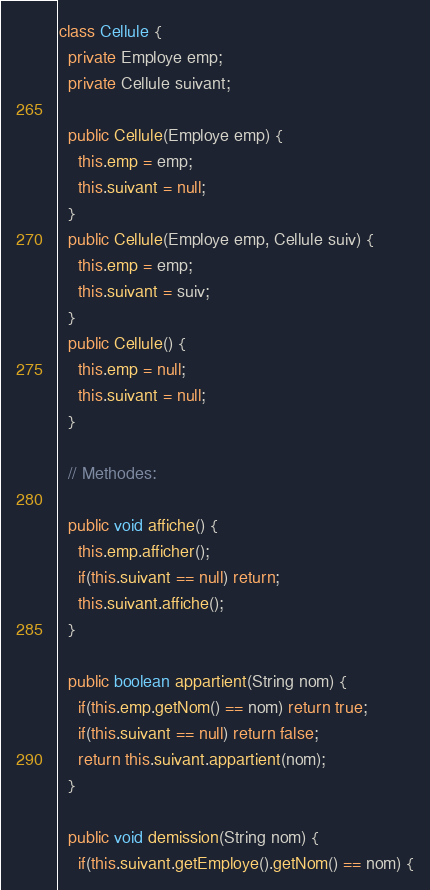Convert code to text. <code><loc_0><loc_0><loc_500><loc_500><_Java_>class Cellule {
  private Employe emp;
  private Cellule suivant;

  public Cellule(Employe emp) {
    this.emp = emp;
    this.suivant = null;
  }
  public Cellule(Employe emp, Cellule suiv) {
    this.emp = emp;
    this.suivant = suiv;
  }
  public Cellule() {
    this.emp = null;
    this.suivant = null;
  }

  // Methodes:

  public void affiche() {
    this.emp.afficher();
    if(this.suivant == null) return;
    this.suivant.affiche();
  }

  public boolean appartient(String nom) {
    if(this.emp.getNom() == nom) return true;
    if(this.suivant == null) return false;
    return this.suivant.appartient(nom);
  }

  public void demission(String nom) {
    if(this.suivant.getEmploye().getNom() == nom) {</code> 